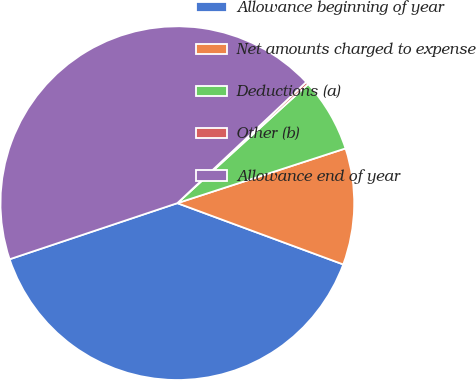Convert chart. <chart><loc_0><loc_0><loc_500><loc_500><pie_chart><fcel>Allowance beginning of year<fcel>Net amounts charged to expense<fcel>Deductions (a)<fcel>Other (b)<fcel>Allowance end of year<nl><fcel>39.23%<fcel>10.64%<fcel>6.75%<fcel>0.25%<fcel>43.13%<nl></chart> 